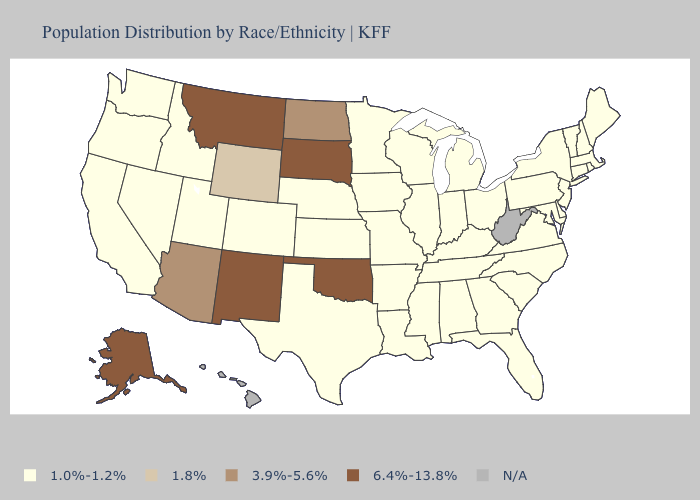Does Oklahoma have the highest value in the USA?
Write a very short answer. Yes. What is the lowest value in the MidWest?
Write a very short answer. 1.0%-1.2%. Name the states that have a value in the range 1.8%?
Concise answer only. Wyoming. How many symbols are there in the legend?
Concise answer only. 5. Name the states that have a value in the range 3.9%-5.6%?
Write a very short answer. Arizona, North Dakota. Does Nebraska have the lowest value in the USA?
Quick response, please. Yes. Does North Dakota have the lowest value in the USA?
Quick response, please. No. What is the value of Ohio?
Concise answer only. 1.0%-1.2%. Which states have the highest value in the USA?
Write a very short answer. Alaska, Montana, New Mexico, Oklahoma, South Dakota. Name the states that have a value in the range 1.8%?
Give a very brief answer. Wyoming. Which states have the highest value in the USA?
Quick response, please. Alaska, Montana, New Mexico, Oklahoma, South Dakota. Is the legend a continuous bar?
Give a very brief answer. No. Name the states that have a value in the range 1.0%-1.2%?
Answer briefly. Alabama, Arkansas, California, Colorado, Connecticut, Delaware, Florida, Georgia, Idaho, Illinois, Indiana, Iowa, Kansas, Kentucky, Louisiana, Maine, Maryland, Massachusetts, Michigan, Minnesota, Mississippi, Missouri, Nebraska, Nevada, New Hampshire, New Jersey, New York, North Carolina, Ohio, Oregon, Pennsylvania, Rhode Island, South Carolina, Tennessee, Texas, Utah, Vermont, Virginia, Washington, Wisconsin. What is the value of Utah?
Be succinct. 1.0%-1.2%. 